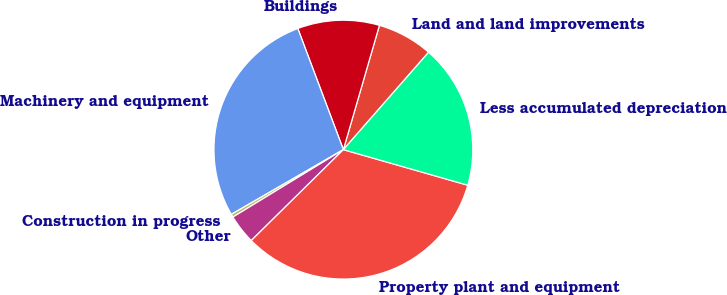Convert chart. <chart><loc_0><loc_0><loc_500><loc_500><pie_chart><fcel>Land and land improvements<fcel>Buildings<fcel>Machinery and equipment<fcel>Construction in progress<fcel>Other<fcel>Property plant and equipment<fcel>Less accumulated depreciation<nl><fcel>6.95%<fcel>10.22%<fcel>27.61%<fcel>0.39%<fcel>3.67%<fcel>33.17%<fcel>17.99%<nl></chart> 